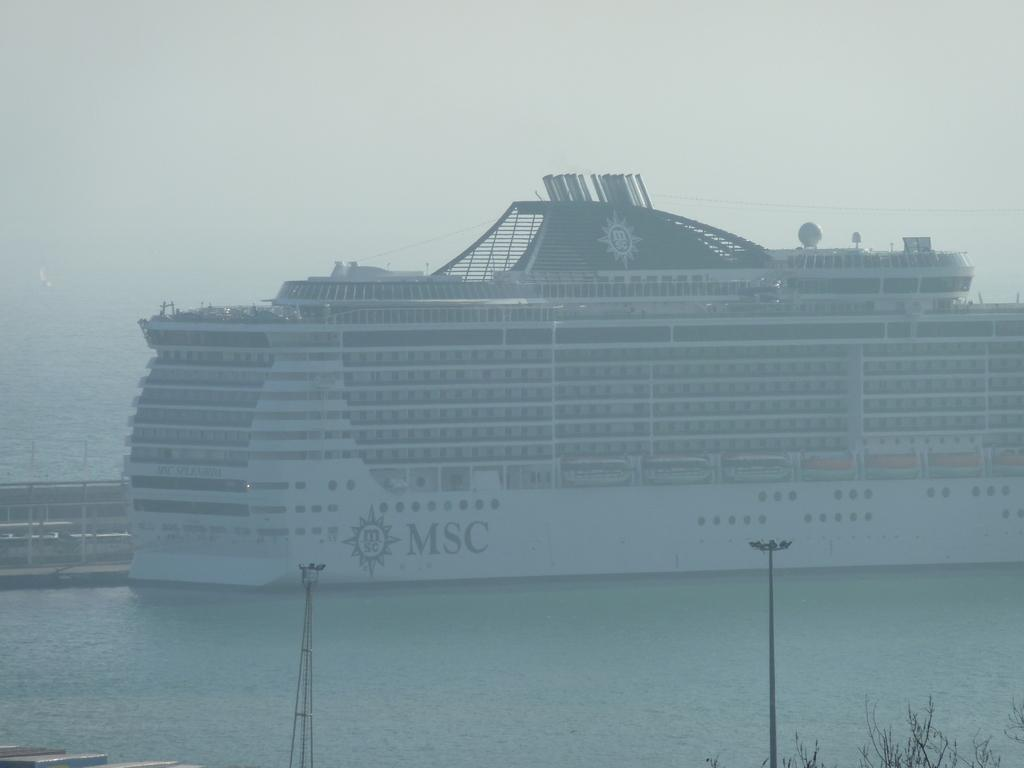What is the main subject of the image? The main subject of the image is a big ship. What color is the ship? The ship is white in color. Where is the ship located? The ship is in the sea. What is visible at the top of the image? The sky is visible at the top of the image. What type of skirt is the authority wearing in the image? There is no authority or skirt present in the image; it features a big white ship in the sea. What discovery was made by the ship in the image? The image does not depict any specific discovery made by the ship; it simply shows the ship in the sea. 